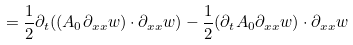<formula> <loc_0><loc_0><loc_500><loc_500>= \frac { 1 } { 2 } \partial _ { t } ( ( A _ { 0 } \partial _ { x x } w ) \cdot \partial _ { x x } w ) - \frac { 1 } { 2 } ( \partial _ { t } A _ { 0 } \partial _ { x x } w ) \cdot \partial _ { x x } w</formula> 